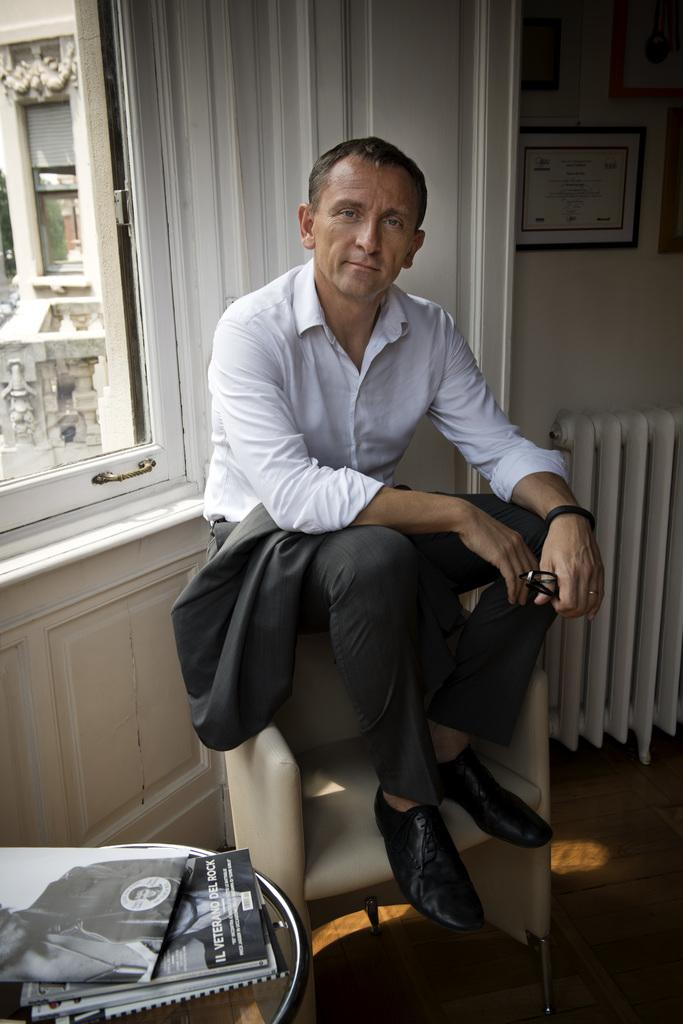What is the man in the image doing? The man is sitting on a chair in the image. Can you describe the location of the window in relation to the man? The window is on the right side of the man. What type of thread is being used to hold up the property in the image? There is no thread or property mentioned in the image; it only shows a man sitting on a chair with a window on the right side. 